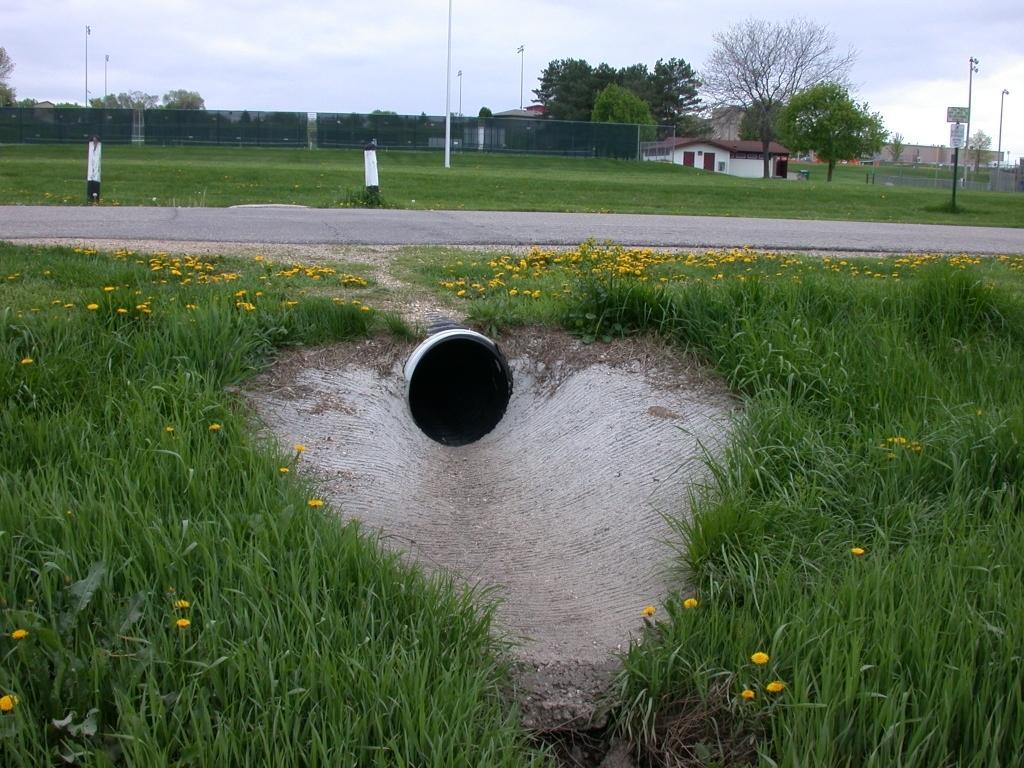In one or two sentences, can you explain what this image depicts? In the middle of the image, we can see a pipe under the road. At the bottom of the image, we can see grass and yellow color flowers. In the background of the image, we can see fence, poles, trees, board and buildings. At the top of the image, the sky is covered with clouds. 